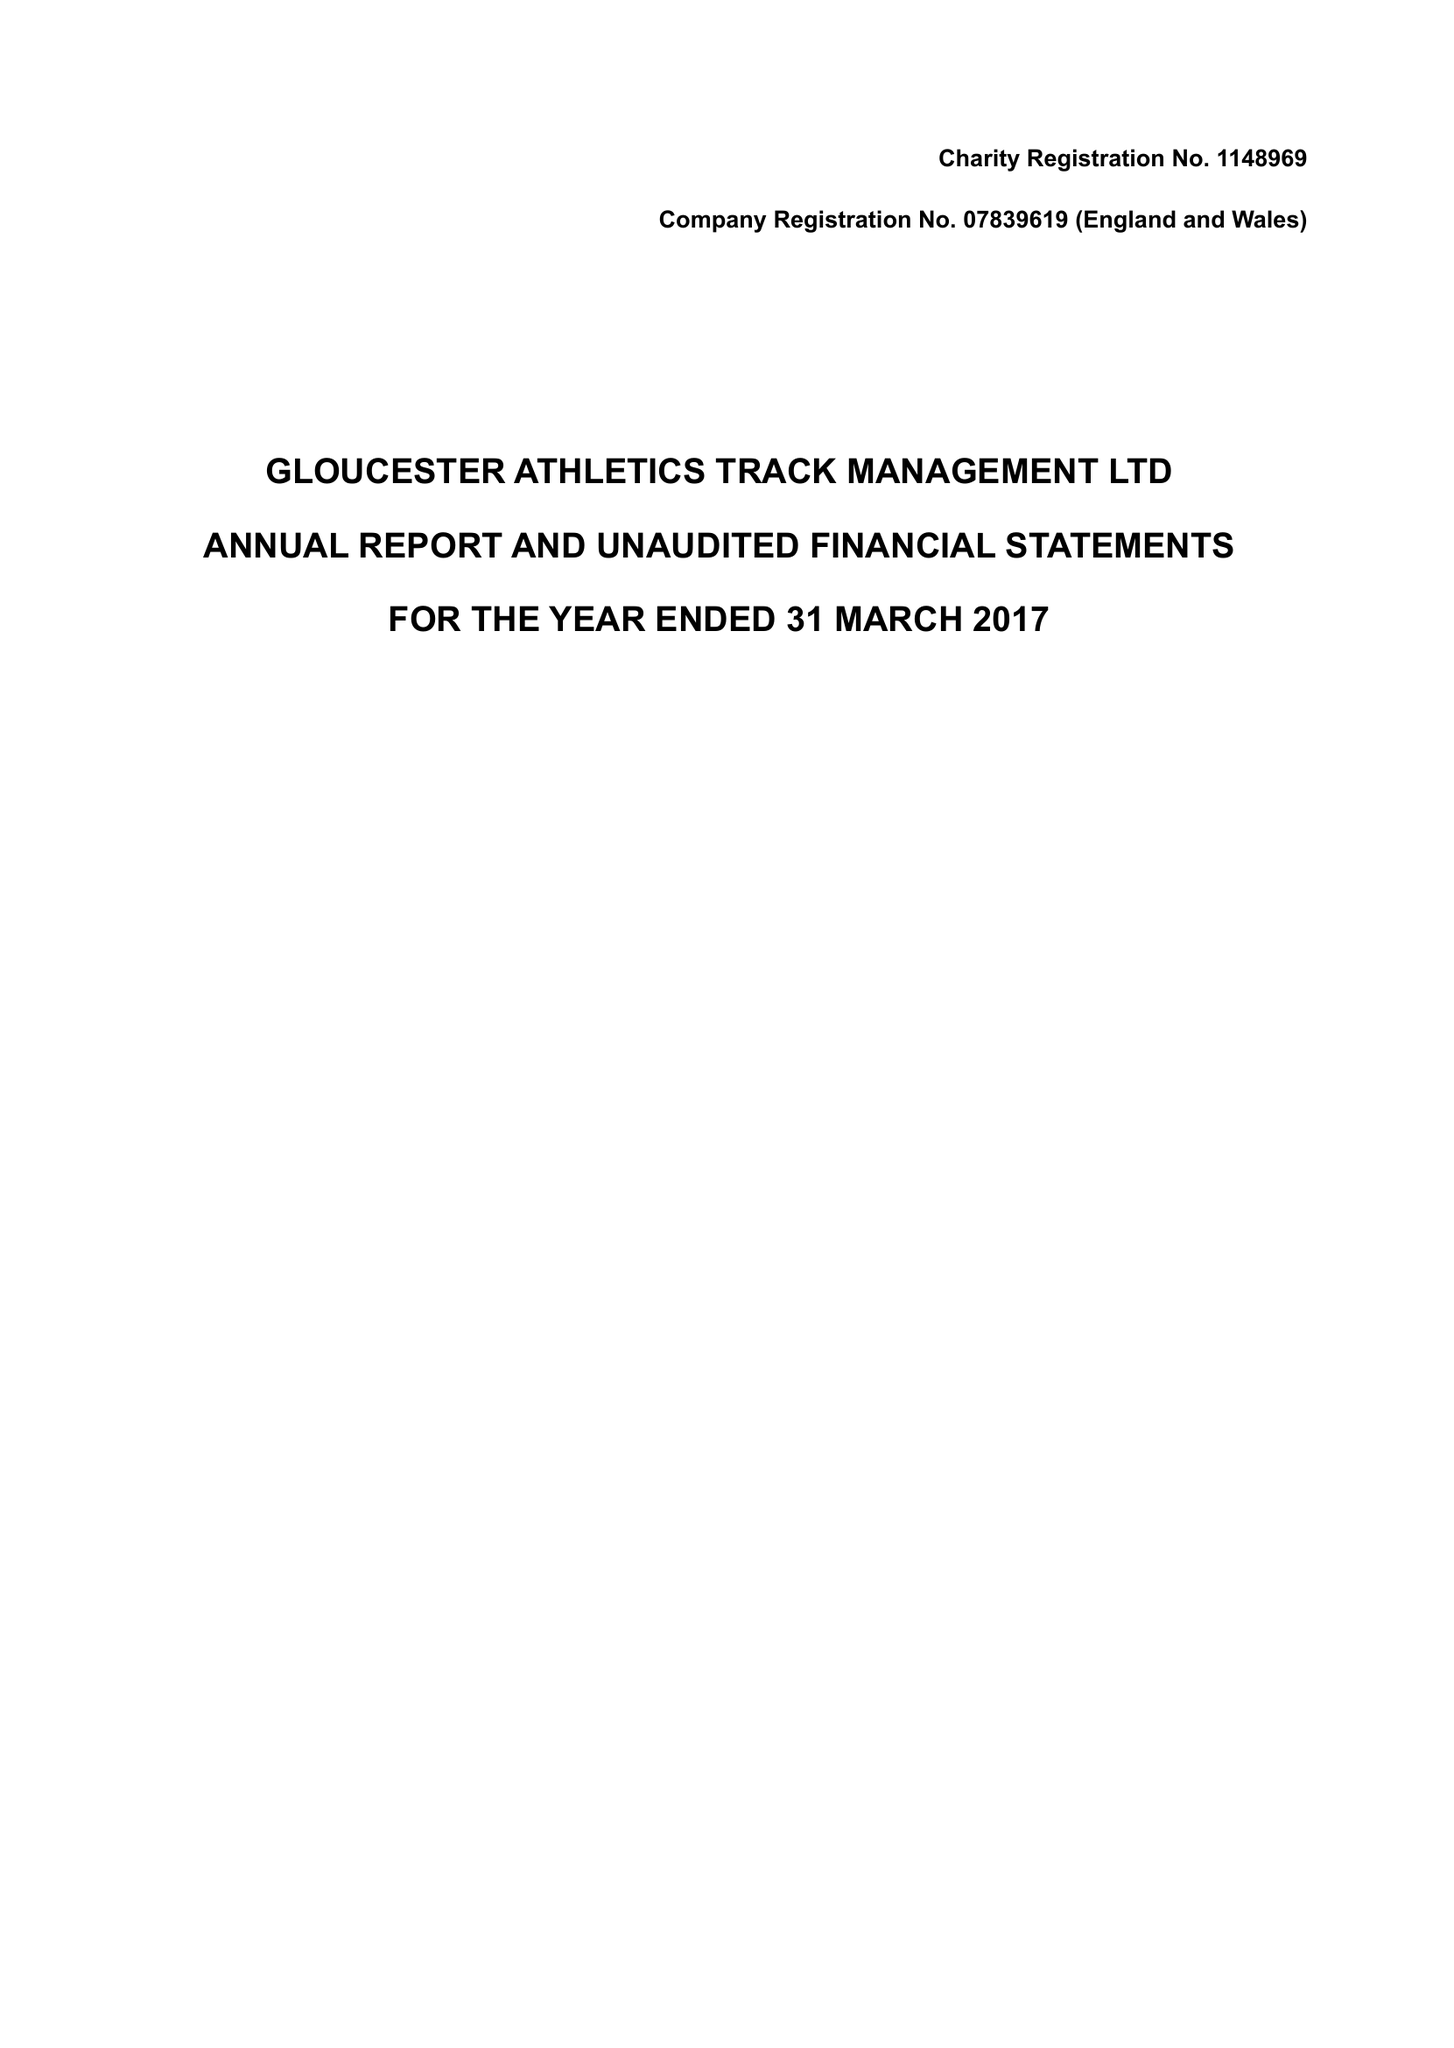What is the value for the address__postcode?
Answer the question using a single word or phrase. GL4 0BJ 